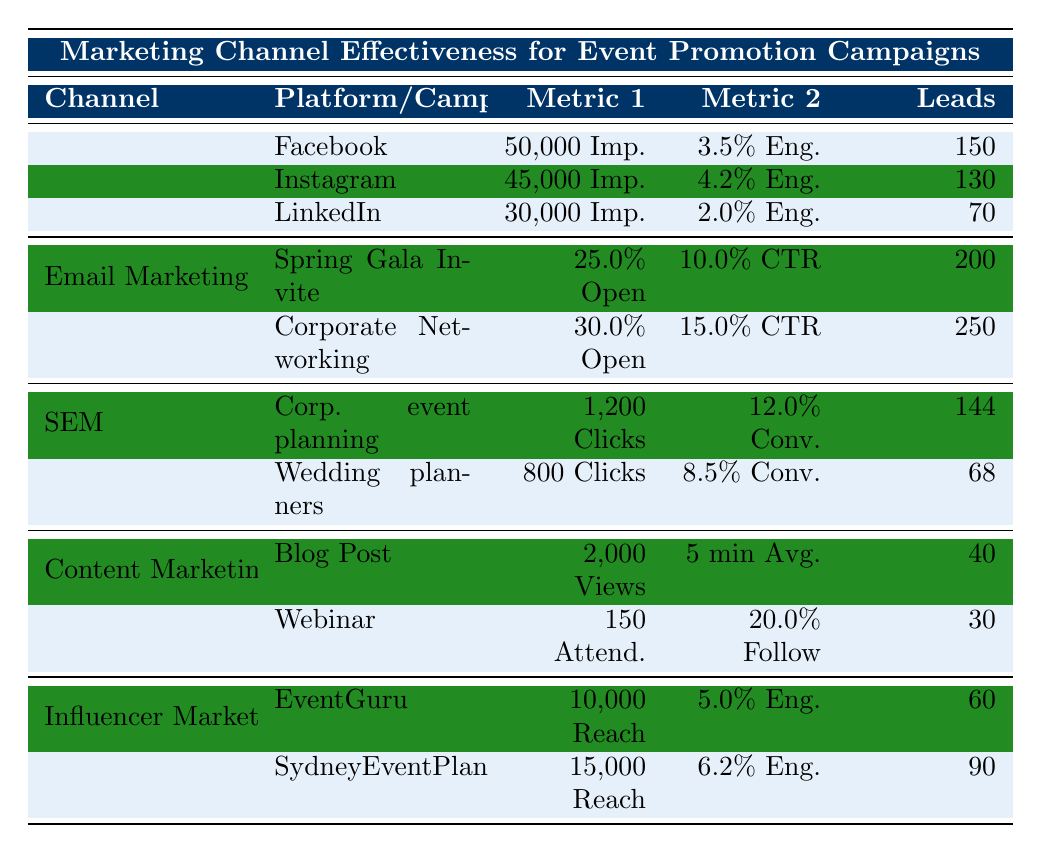What's the total number of leads generated from Email Marketing? The table lists two campaigns under Email Marketing: "Spring Gala Invite" with 200 leads and "Corporate Networking Event" with 250 leads. Adding these together gives 200 + 250 = 450 leads.
Answer: 450 Which social media platform had the highest engagement rate? The engagement rates for the platforms are: Facebook 3.5%, Instagram 4.2%, and LinkedIn 2.0%. The highest engagement rate is 4.2% from Instagram.
Answer: Instagram How many total impressions were generated from Social Media? The impressions for Facebook, Instagram, and LinkedIn are 50,000, 45,000, and 30,000 respectively. Adding them gives 50,000 + 45,000 + 30,000 = 125,000 impressions.
Answer: 125,000 What is the average conversion rate for SEM campaigns? The conversion rates for the two SEM keywords are 12.0% for "corporate event planning Sydney" and 8.5% for "wedding planners Sydney". To find the average, sum these rates (12.0 + 8.5) and divide by 2, giving (20.5 / 2) = 10.25%.
Answer: 10.25% Did the "Webinar" generate more leads than the "Blog Post"? The "Webinar" generated 30 leads while the "Blog Post" generated 40 leads. Since 30 is less than 40, the statement is false.
Answer: No Which marketing channel generated the least leads? Evaluating leads generated across all channels: Social Media (350), Email Marketing (450), SEM (212), Content Marketing (70), Influencer Marketing (150). The least is 70 leads from Content Marketing.
Answer: Content Marketing What is the total reach of the influencers listed? The reach for "EventGuru" is 10,000 and for "SydneyEventPlanner" is 15,000. Adding these amounts gives a total reach of 10,000 + 15,000 = 25,000.
Answer: 25,000 Which campaign had a higher click-through rate, "Spring Gala Invite" or "Corporate Networking Event"? The click-through rates are 10.0% for "Spring Gala Invite" and 15.0% for "Corporate Networking Event". Comparing these shows that 15.0% is greater than 10.0%.
Answer: Corporate Networking Event What was the total number of leads generated by Influencer Marketing? The leads generated by "EventGuru" are 60 and "SydneyEventPlanner" are 90. Adding these gives 60 + 90 = 150 leads.
Answer: 150 Calculate the percentage of leads generated by LinkedIn compared to the total leads from Social Media. LinkedIn had 70 leads. The total leads from Social Media are 350 (sum of leads from Facebook, Instagram, and LinkedIn). The percentage is (70 / 350) * 100 = 20%.
Answer: 20% 